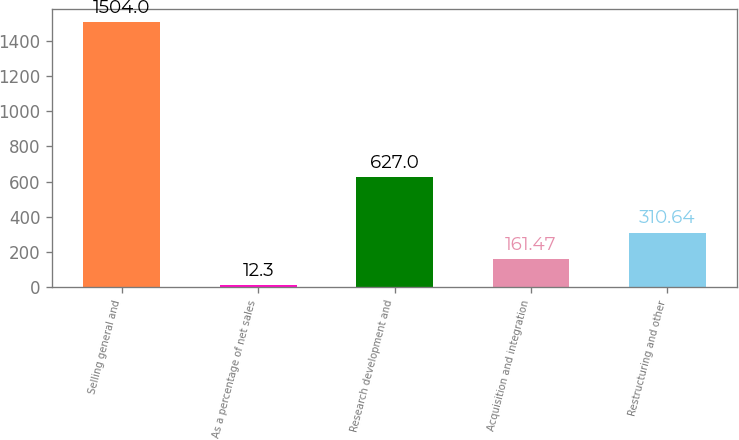Convert chart. <chart><loc_0><loc_0><loc_500><loc_500><bar_chart><fcel>Selling general and<fcel>As a percentage of net sales<fcel>Research development and<fcel>Acquisition and integration<fcel>Restructuring and other<nl><fcel>1504<fcel>12.3<fcel>627<fcel>161.47<fcel>310.64<nl></chart> 